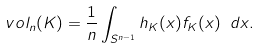Convert formula to latex. <formula><loc_0><loc_0><loc_500><loc_500>\ v o l _ { n } ( K ) = \frac { 1 } { n } \int _ { S ^ { n - 1 } } h _ { K } ( x ) f _ { K } ( x ) \ d x .</formula> 